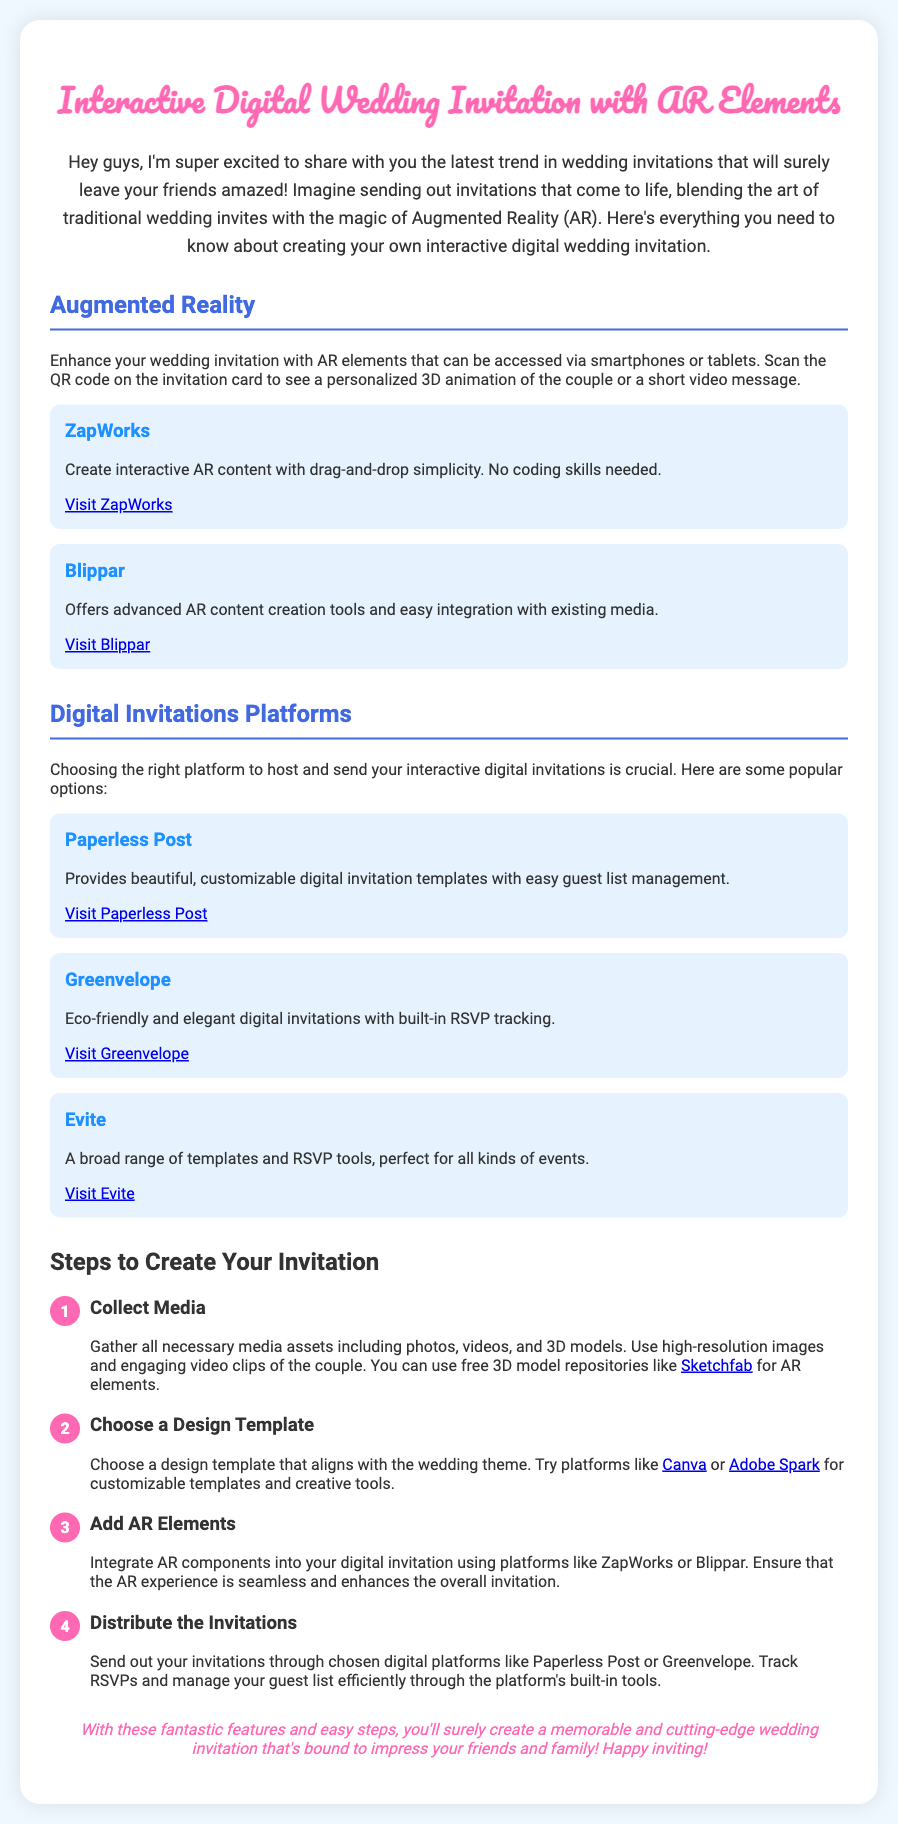what is the main theme of the invitation? The main theme revolves around creating an interactive digital wedding invitation with Augmented Reality elements.
Answer: Interactive Digital Wedding Invitation with AR Elements how can guests access the AR content? Guests can access the AR content by scanning the QR code on the invitation card using smartphones or tablets.
Answer: Scanning the QR code which platform is recommended for creating interactive AR content? The document mentions two platforms for creating interactive AR content, one of which is ZapWorks.
Answer: ZapWorks what is the color scheme used for the heading? The heading uses pink as its primary color for the title.
Answer: Pink how many steps are outlined for creating the invitation? There are four steps outlined in the document for creating the invitation.
Answer: Four steps which digital invitation platform offers RSVP tracking? The platform Greenvelope is mentioned as offering built-in RSVP tracking.
Answer: Greenvelope what type of media should be collected for the invitation? The media assets should include photos, videos, and 3D models.
Answer: Photos, videos, and 3D models what is the purpose of using Augmented Reality in wedding invitations? The purpose is to enhance the wedding invitation experience with personalized 3D animations or video messages.
Answer: Enhance the experience which tool is suggested for customizable digital invitation templates? Canva is suggested as a tool for customizable digital invitation templates.
Answer: Canva 